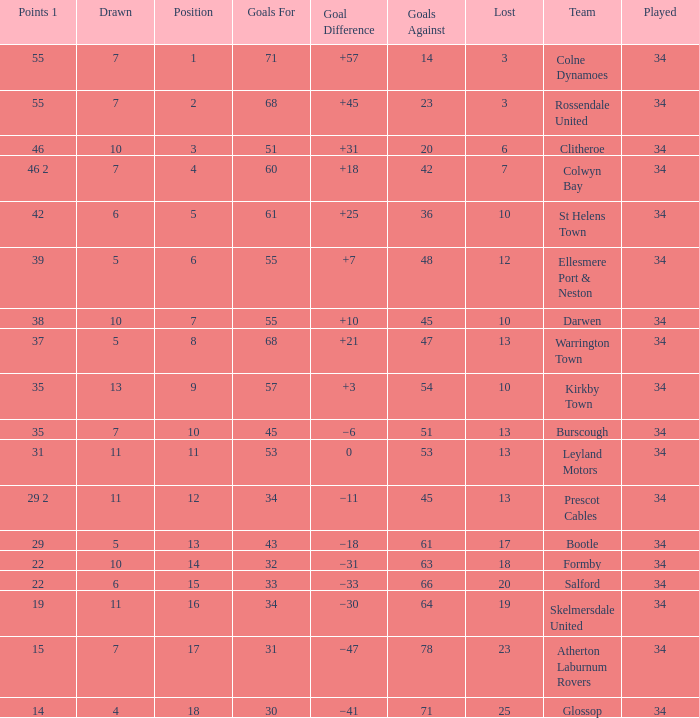Would you mind parsing the complete table? {'header': ['Points 1', 'Drawn', 'Position', 'Goals For', 'Goal Difference', 'Goals Against', 'Lost', 'Team', 'Played'], 'rows': [['55', '7', '1', '71', '+57', '14', '3', 'Colne Dynamoes', '34'], ['55', '7', '2', '68', '+45', '23', '3', 'Rossendale United', '34'], ['46', '10', '3', '51', '+31', '20', '6', 'Clitheroe', '34'], ['46 2', '7', '4', '60', '+18', '42', '7', 'Colwyn Bay', '34'], ['42', '6', '5', '61', '+25', '36', '10', 'St Helens Town', '34'], ['39', '5', '6', '55', '+7', '48', '12', 'Ellesmere Port & Neston', '34'], ['38', '10', '7', '55', '+10', '45', '10', 'Darwen', '34'], ['37', '5', '8', '68', '+21', '47', '13', 'Warrington Town', '34'], ['35', '13', '9', '57', '+3', '54', '10', 'Kirkby Town', '34'], ['35', '7', '10', '45', '−6', '51', '13', 'Burscough', '34'], ['31', '11', '11', '53', '0', '53', '13', 'Leyland Motors', '34'], ['29 2', '11', '12', '34', '−11', '45', '13', 'Prescot Cables', '34'], ['29', '5', '13', '43', '−18', '61', '17', 'Bootle', '34'], ['22', '10', '14', '32', '−31', '63', '18', 'Formby', '34'], ['22', '6', '15', '33', '−33', '66', '20', 'Salford', '34'], ['19', '11', '16', '34', '−30', '64', '19', 'Skelmersdale United', '34'], ['15', '7', '17', '31', '−47', '78', '23', 'Atherton Laburnum Rovers', '34'], ['14', '4', '18', '30', '−41', '71', '25', 'Glossop', '34']]} Which Goals For has a Lost of 12, and a Played larger than 34? None. 